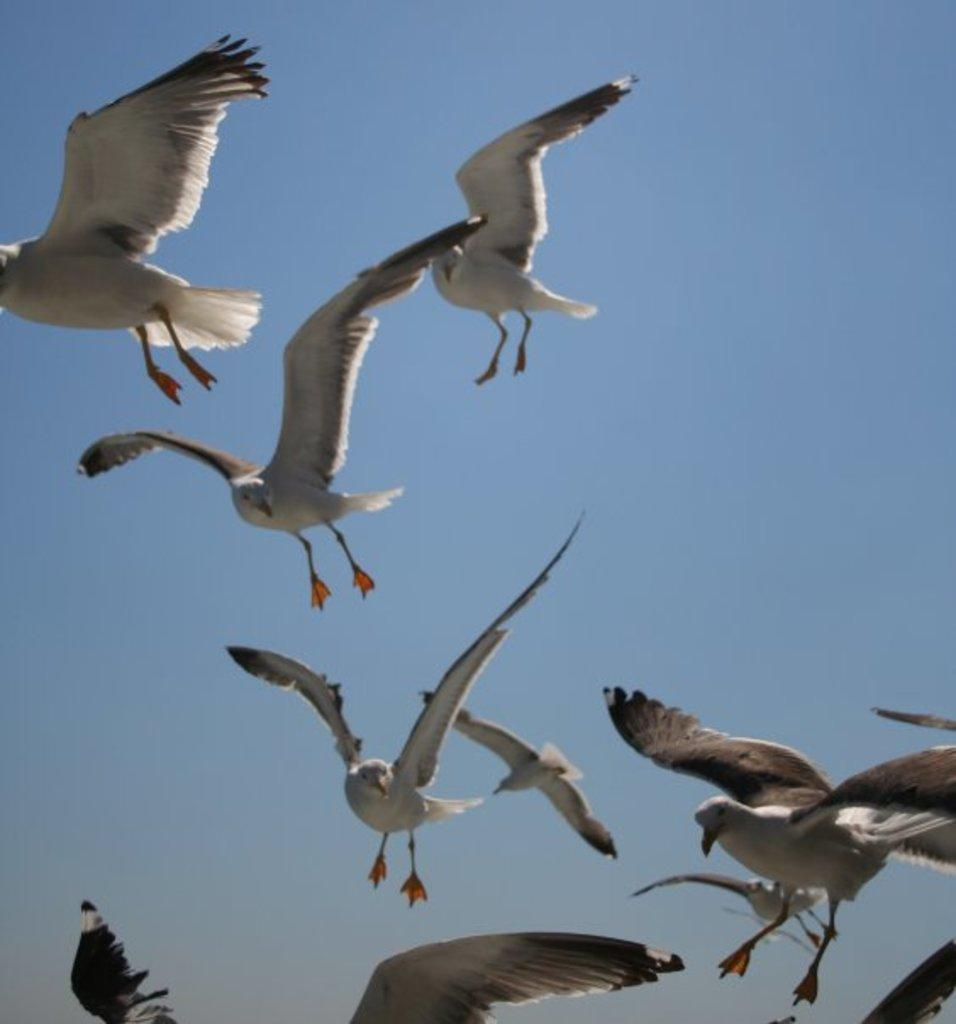What type of animals can be seen in the image? There are birds in the image. What are the birds doing in the image? The birds are flying. What color is the sky in the background of the image? The sky in the background of the image is blue. Is there a scarecrow present in the image? No, there is no scarecrow present in the image. What form does the property take in the image? The image does not depict any property, so it is not possible to describe its form. 